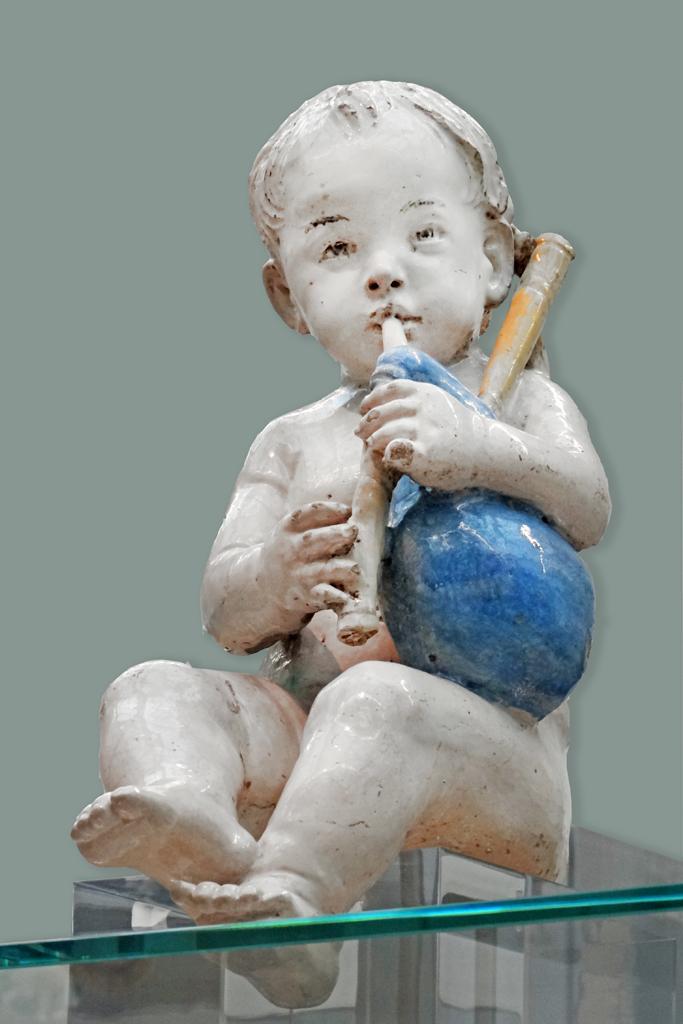Can you describe this image briefly? In this image there is a statue of a kid. At the bottom of the image there is a glass. 